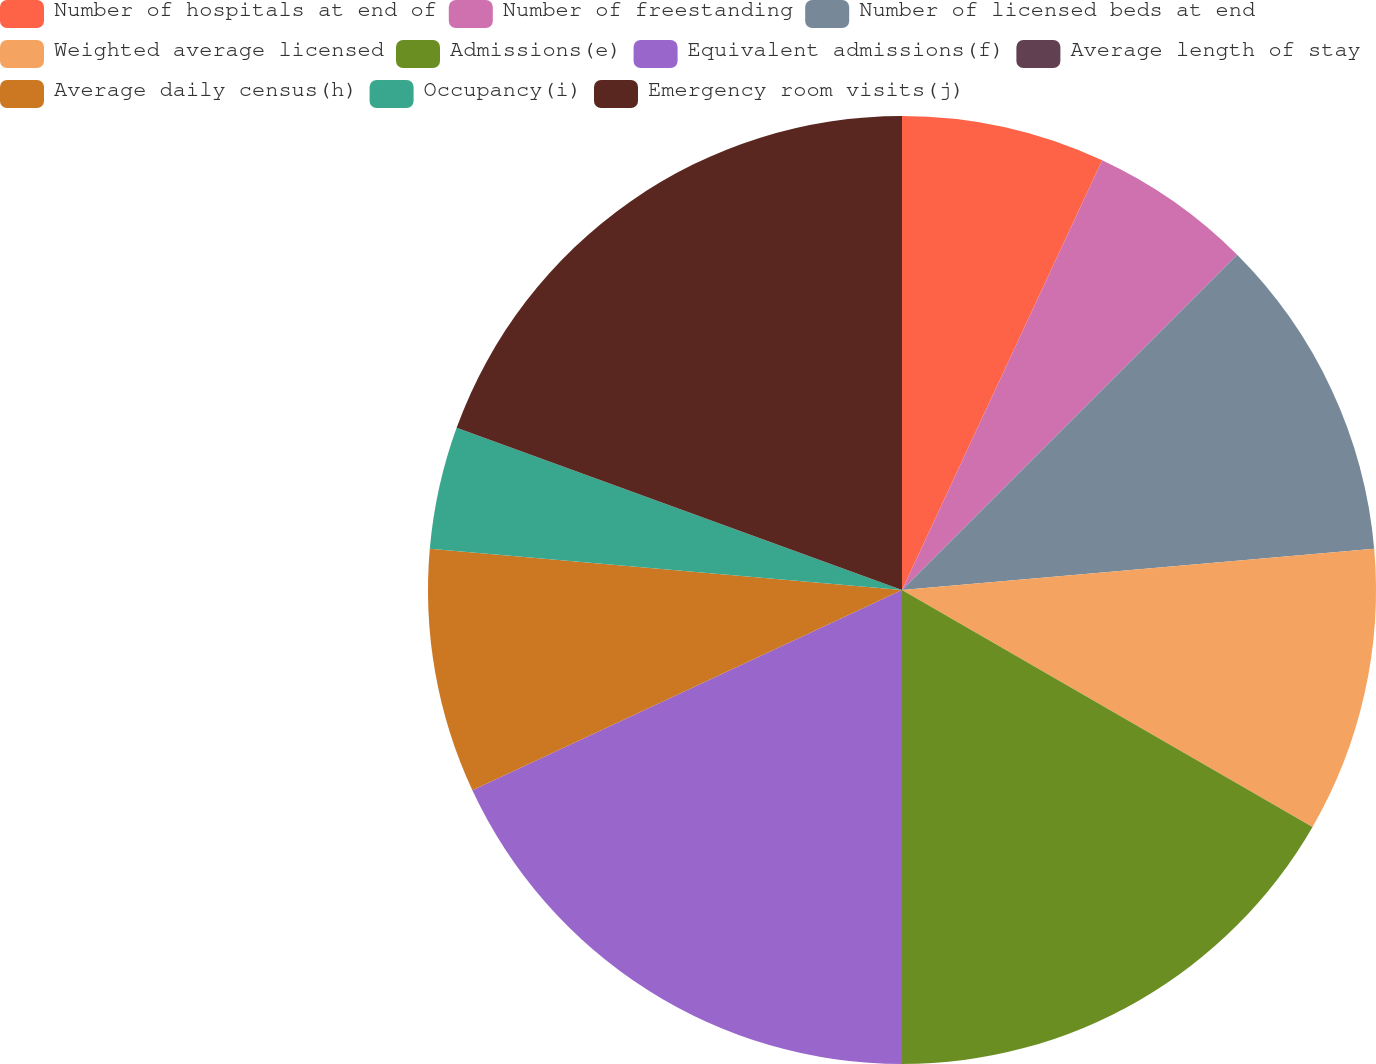<chart> <loc_0><loc_0><loc_500><loc_500><pie_chart><fcel>Number of hospitals at end of<fcel>Number of freestanding<fcel>Number of licensed beds at end<fcel>Weighted average licensed<fcel>Admissions(e)<fcel>Equivalent admissions(f)<fcel>Average length of stay<fcel>Average daily census(h)<fcel>Occupancy(i)<fcel>Emergency room visits(j)<nl><fcel>6.94%<fcel>5.56%<fcel>11.11%<fcel>9.72%<fcel>16.67%<fcel>18.06%<fcel>0.0%<fcel>8.33%<fcel>4.17%<fcel>19.44%<nl></chart> 